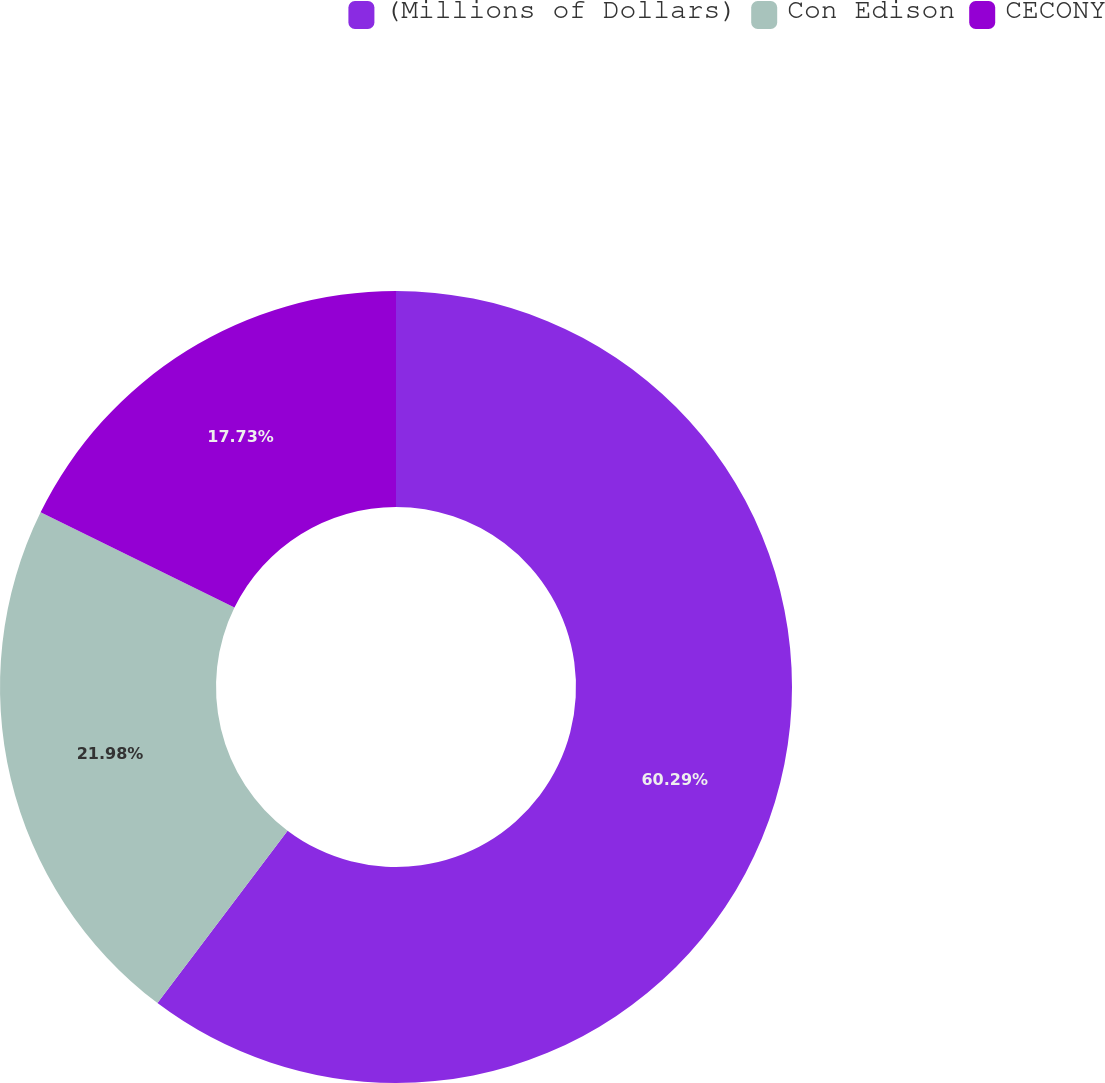<chart> <loc_0><loc_0><loc_500><loc_500><pie_chart><fcel>(Millions of Dollars)<fcel>Con Edison<fcel>CECONY<nl><fcel>60.29%<fcel>21.98%<fcel>17.73%<nl></chart> 